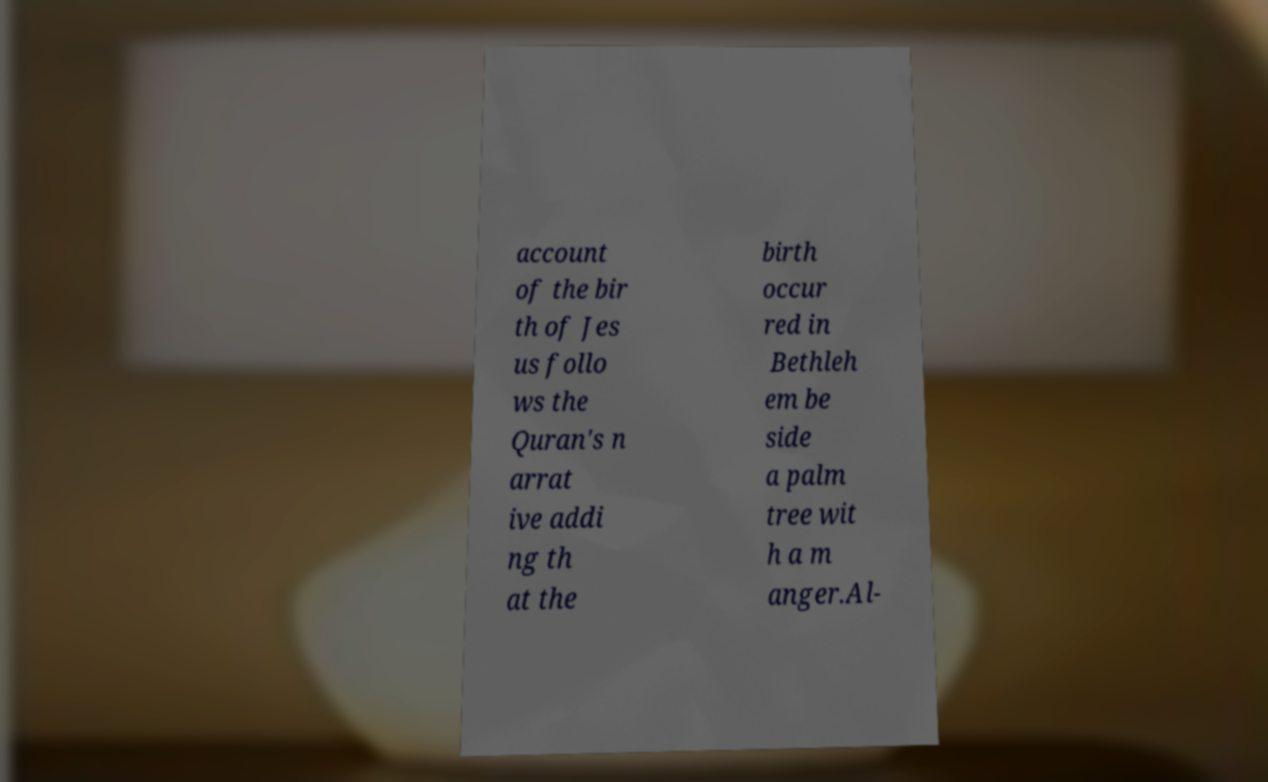Can you read and provide the text displayed in the image?This photo seems to have some interesting text. Can you extract and type it out for me? account of the bir th of Jes us follo ws the Quran's n arrat ive addi ng th at the birth occur red in Bethleh em be side a palm tree wit h a m anger.Al- 